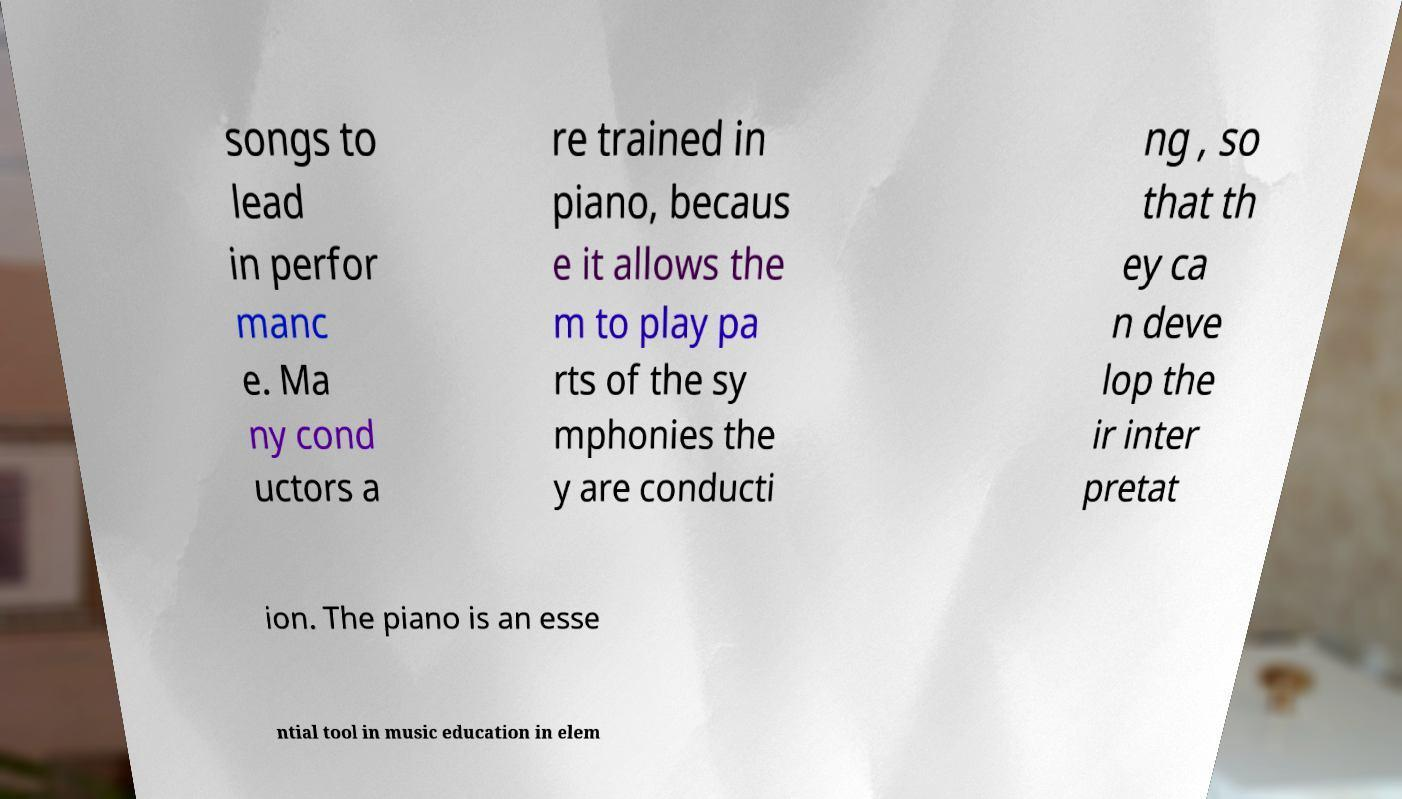Please read and relay the text visible in this image. What does it say? songs to lead in perfor manc e. Ma ny cond uctors a re trained in piano, becaus e it allows the m to play pa rts of the sy mphonies the y are conducti ng , so that th ey ca n deve lop the ir inter pretat ion. The piano is an esse ntial tool in music education in elem 